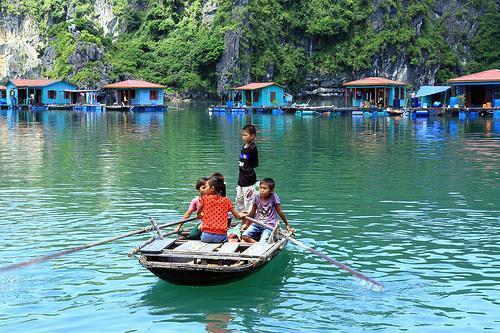How many huts are there?
Give a very brief answer. 5. How many people are in the boat?
Give a very brief answer. 4. 